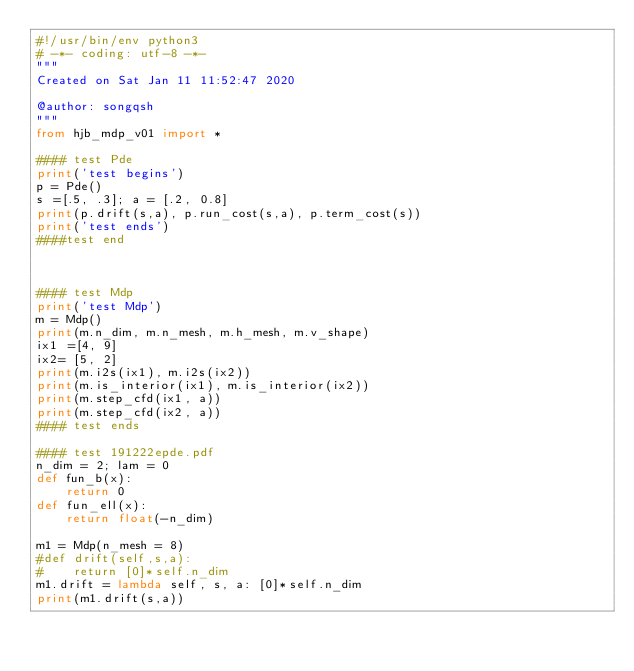<code> <loc_0><loc_0><loc_500><loc_500><_Python_>#!/usr/bin/env python3
# -*- coding: utf-8 -*-
"""
Created on Sat Jan 11 11:52:47 2020

@author: songqsh
"""
from hjb_mdp_v01 import *

#### test Pde
print('test begins')
p = Pde()
s =[.5, .3]; a = [.2, 0.8]
print(p.drift(s,a), p.run_cost(s,a), p.term_cost(s))
print('test ends')
####test end


    
#### test Mdp
print('test Mdp')
m = Mdp()
print(m.n_dim, m.n_mesh, m.h_mesh, m.v_shape)
ix1 =[4, 9]
ix2= [5, 2]
print(m.i2s(ix1), m.i2s(ix2))
print(m.is_interior(ix1), m.is_interior(ix2))
print(m.step_cfd(ix1, a))
print(m.step_cfd(ix2, a))
#### test ends

#### test 191222epde.pdf
n_dim = 2; lam = 0
def fun_b(x):
    return 0
def fun_ell(x):
    return float(-n_dim)

m1 = Mdp(n_mesh = 8)
#def drift(self,s,a):
#    return [0]*self.n_dim
m1.drift = lambda self, s, a: [0]*self.n_dim
print(m1.drift(s,a))

    </code> 